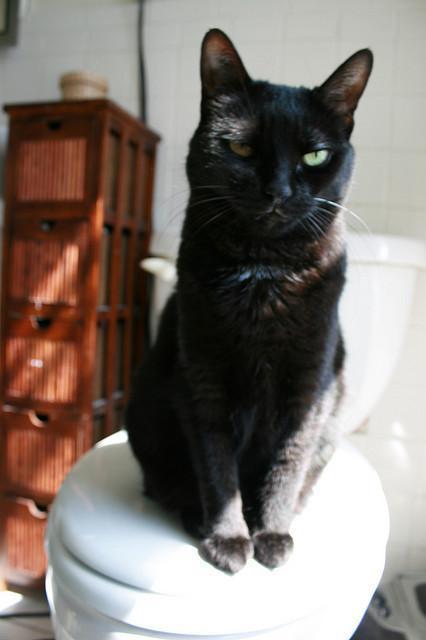How many people are in the photograph in the background?
Give a very brief answer. 0. 